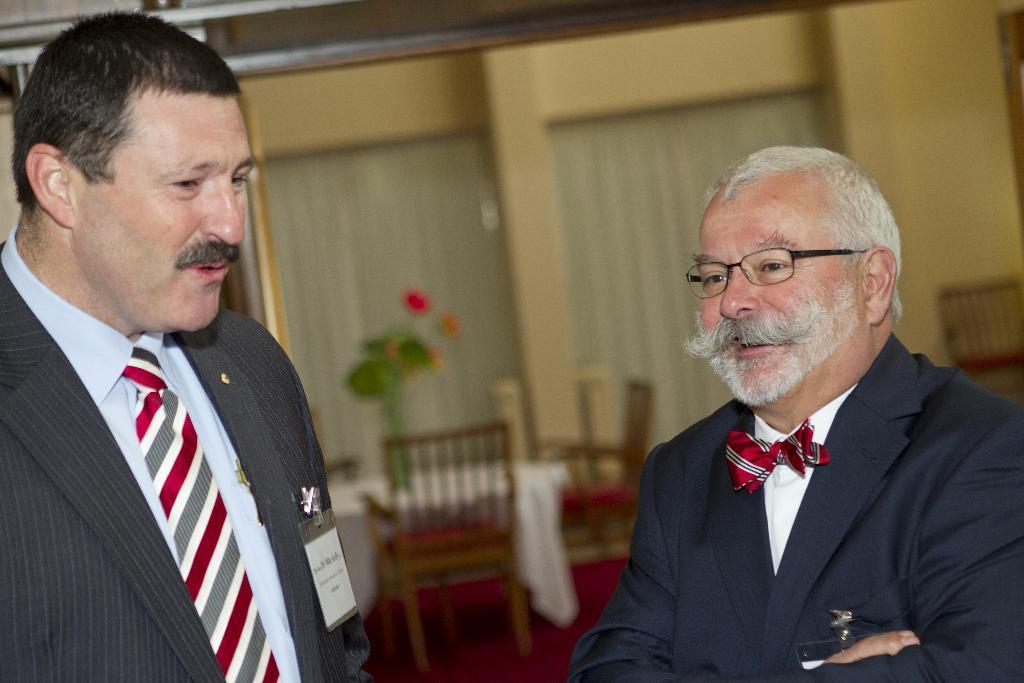Could you give a brief overview of what you see in this image? In this image i can see a people smiling and behind them i can see chairs and flower pot. 